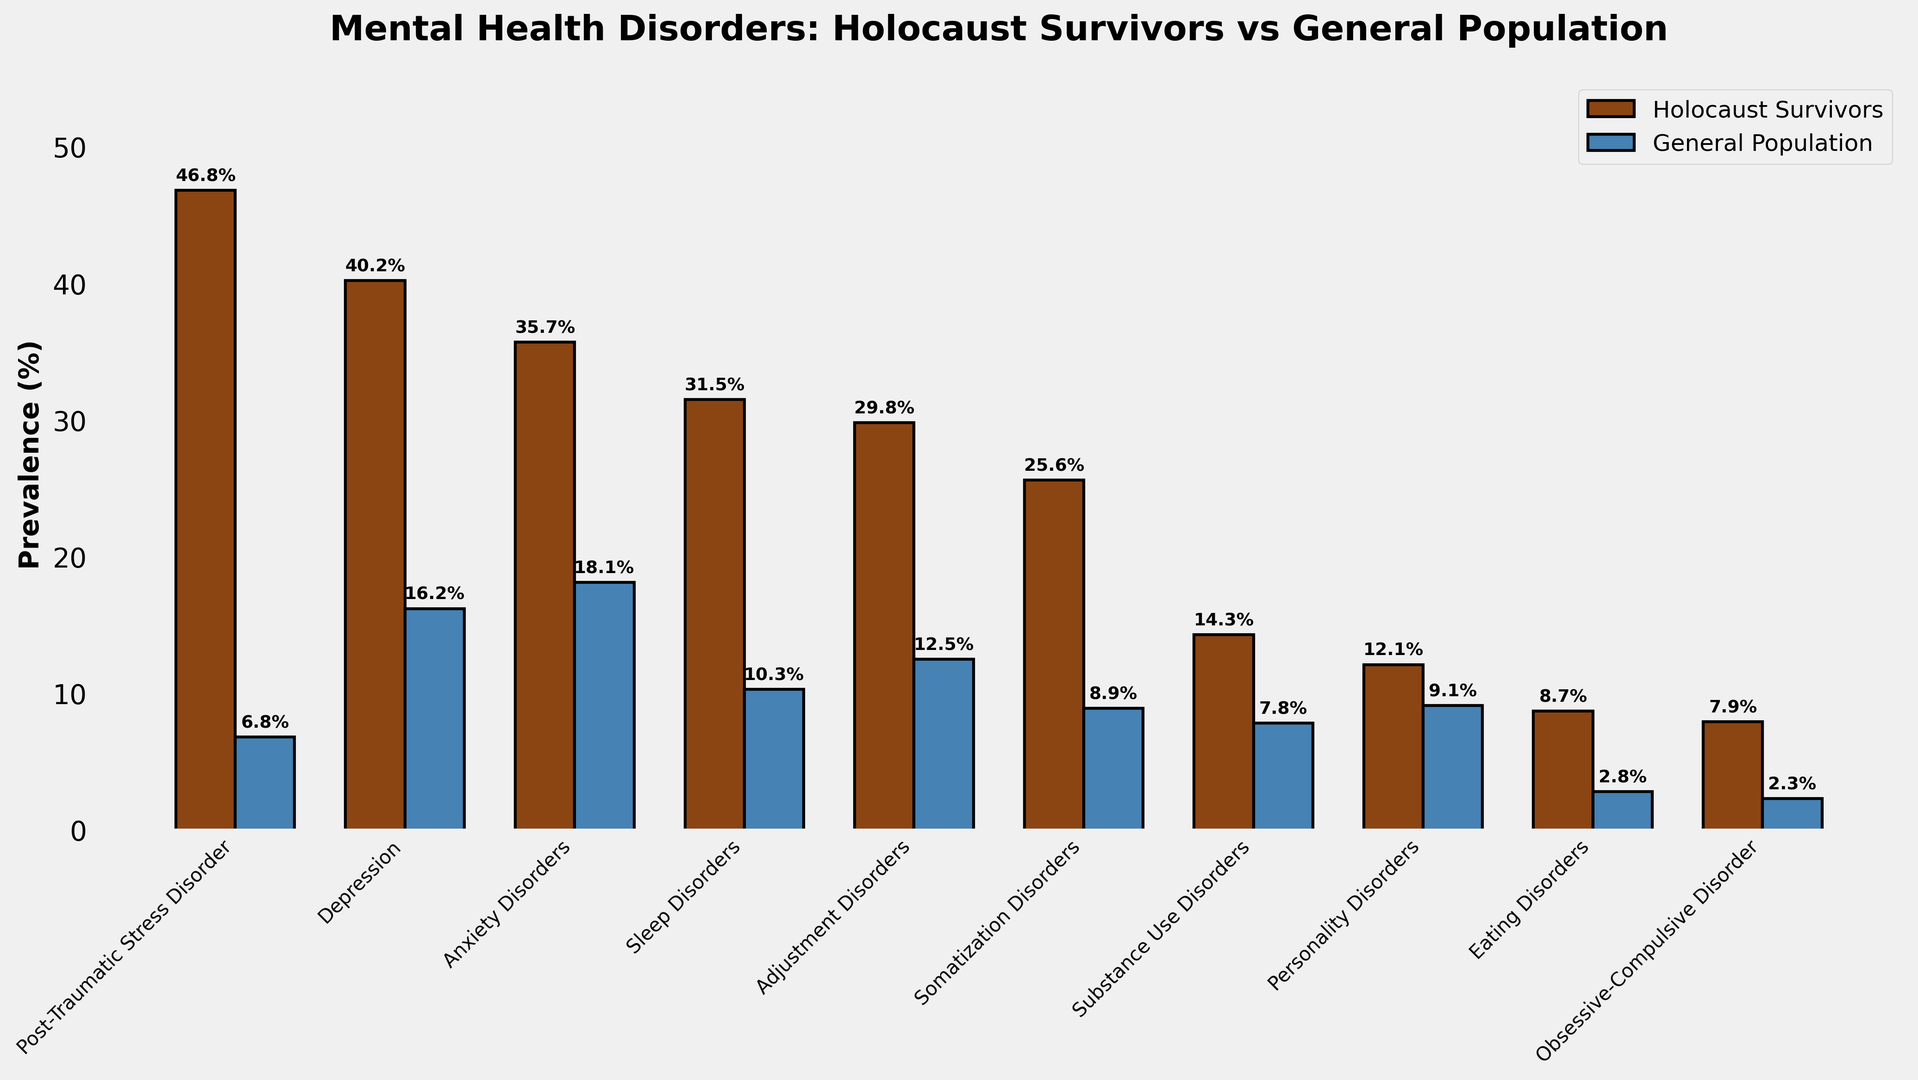What is the difference in the prevalence of Post-Traumatic Stress Disorder (PTSD) between Holocaust survivors and the general population? To find the difference in the prevalence of PTSD between the two groups, look at the heights of the bars for PTSD. The bar for Holocaust survivors indicates 46.8%, and the bar for the general population indicates 6.8%. Subtract 6.8 from 46.8 to get the difference.
Answer: 40% Which disorder has the biggest difference in prevalence between Holocaust survivors and the general population? To determine which disorder has the biggest difference, calculate the difference for each disorder by subtracting the general population percentage from the Holocaust survivors percentage. The disorder with the largest difference is Post-Traumatic Stress Disorder (PTSD), with a difference of 40%.
Answer: Post-Traumatic Stress Disorder What is the combined prevalence of Anxiety and Sleep Disorders among Holocaust survivors? To find the combined prevalence, add the percentages for Anxiety Disorders and Sleep Disorders among Holocaust survivors. The prevalence for Anxiety Disorders is 35.7%, and for Sleep Disorders, it is 31.5%. Adding these together, 35.7 + 31.5 = 67.2%.
Answer: 67.2% How does the prevalence of Eating Disorders compare between Holocaust survivors and the general population? Compare the heights of the bars for Eating Disorders. Holocaust survivors have a prevalence of 8.7%, while the general population has a prevalence of 2.8%. This shows that Holocaust survivors have a higher prevalence of Eating Disorders.
Answer: Holocaust survivors have a higher prevalence of Eating Disorders Among the listed disorders, which ones have a lower prevalence in Holocaust survivors compared to the general population? Look for the disorders where the bar for the Holocaust survivors is shorter than the bar for the general population. The only disorder where the general population has a higher prevalence is Personality Disorders (12.1% for Holocaust survivors vs. 9.1% for the general population).
Answer: None What is the average prevalence of mental health disorders among the general population based on the listed disorders? First, sum the prevalence percentages for all the listed disorders in the general population, then divide by the number of disorders (10). The sum is 6.8 + 16.2 + 18.1 + 10.3 + 12.5 + 8.9 + 7.8 + 9.1 + 2.8 + 2.3 = 94.8. Dividing by 10, the average prevalence is 94.8 / 10 = 9.48%.
Answer: 9.48% Which disorder has the smallest difference in prevalence between Holocaust survivors and the general population? To determine the disorder with the smallest difference, calculate the difference for each disorder. The disorder with the smallest difference is Obsessive-Compulsive Disorder, with a difference of 7.9% (Holocaust survivors) - 2.3% (general population) = 5.6%.
Answer: Obsessive-Compulsive Disorder How much higher is the prevalence of Depression in Holocaust survivors compared to the general population? Compare the heights of the bars for Depression. The prevalence is 40.2% in Holocaust survivors and 16.2% in the general population. The difference is 40.2 - 16.2 = 24%.
Answer: 24% What is the combined prevalence of Eating and Obsessive-Compulsive Disorders in the general population? Add the prevalence percentages for Eating Disorders and Obsessive-Compulsive Disorders in the general population. Eating Disorders have a prevalence of 2.8%, and Obsessive-Compulsive Disorders have 2.3%. Adding these together, 2.8 + 2.3 = 5.1%.
Answer: 5.1% 